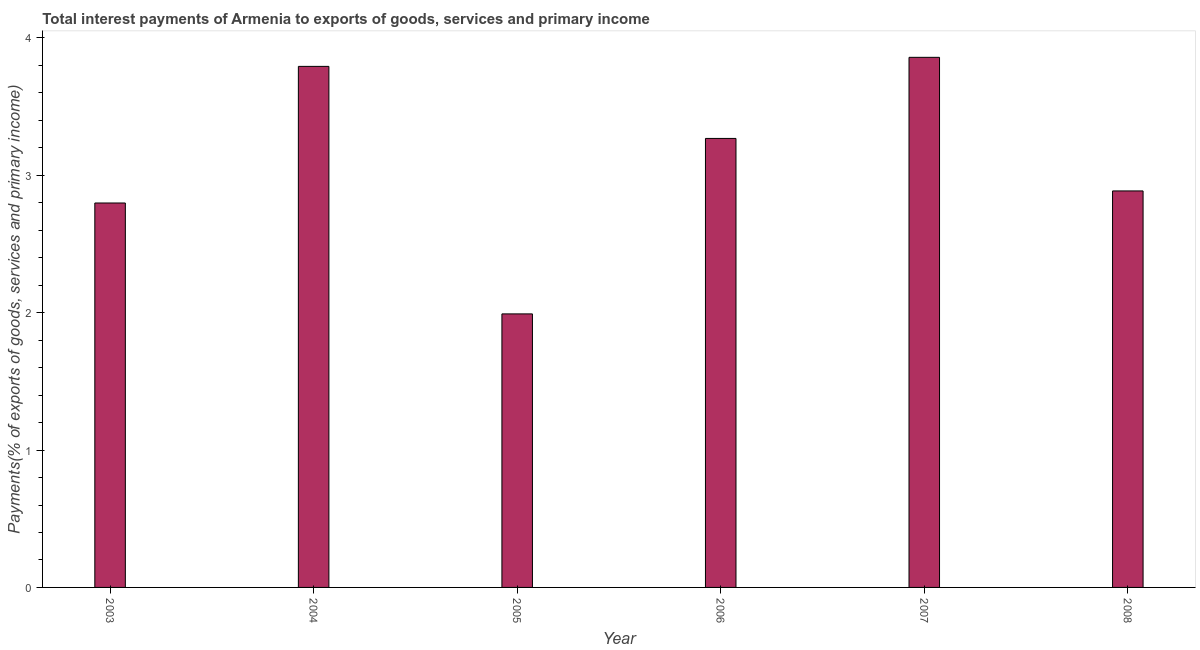What is the title of the graph?
Offer a very short reply. Total interest payments of Armenia to exports of goods, services and primary income. What is the label or title of the X-axis?
Offer a terse response. Year. What is the label or title of the Y-axis?
Ensure brevity in your answer.  Payments(% of exports of goods, services and primary income). What is the total interest payments on external debt in 2004?
Keep it short and to the point. 3.79. Across all years, what is the maximum total interest payments on external debt?
Your answer should be very brief. 3.86. Across all years, what is the minimum total interest payments on external debt?
Provide a short and direct response. 1.99. In which year was the total interest payments on external debt maximum?
Your answer should be compact. 2007. What is the sum of the total interest payments on external debt?
Ensure brevity in your answer.  18.6. What is the difference between the total interest payments on external debt in 2005 and 2008?
Offer a very short reply. -0.9. What is the average total interest payments on external debt per year?
Offer a very short reply. 3.1. What is the median total interest payments on external debt?
Provide a short and direct response. 3.08. Do a majority of the years between 2008 and 2004 (inclusive) have total interest payments on external debt greater than 1.4 %?
Provide a short and direct response. Yes. What is the ratio of the total interest payments on external debt in 2006 to that in 2008?
Keep it short and to the point. 1.13. Is the total interest payments on external debt in 2004 less than that in 2007?
Make the answer very short. Yes. What is the difference between the highest and the second highest total interest payments on external debt?
Give a very brief answer. 0.07. What is the difference between the highest and the lowest total interest payments on external debt?
Your response must be concise. 1.87. In how many years, is the total interest payments on external debt greater than the average total interest payments on external debt taken over all years?
Offer a terse response. 3. What is the Payments(% of exports of goods, services and primary income) of 2003?
Your response must be concise. 2.8. What is the Payments(% of exports of goods, services and primary income) in 2004?
Ensure brevity in your answer.  3.79. What is the Payments(% of exports of goods, services and primary income) of 2005?
Ensure brevity in your answer.  1.99. What is the Payments(% of exports of goods, services and primary income) in 2006?
Your answer should be very brief. 3.27. What is the Payments(% of exports of goods, services and primary income) of 2007?
Provide a short and direct response. 3.86. What is the Payments(% of exports of goods, services and primary income) of 2008?
Offer a terse response. 2.89. What is the difference between the Payments(% of exports of goods, services and primary income) in 2003 and 2004?
Provide a succinct answer. -0.99. What is the difference between the Payments(% of exports of goods, services and primary income) in 2003 and 2005?
Provide a succinct answer. 0.81. What is the difference between the Payments(% of exports of goods, services and primary income) in 2003 and 2006?
Offer a very short reply. -0.47. What is the difference between the Payments(% of exports of goods, services and primary income) in 2003 and 2007?
Offer a very short reply. -1.06. What is the difference between the Payments(% of exports of goods, services and primary income) in 2003 and 2008?
Give a very brief answer. -0.09. What is the difference between the Payments(% of exports of goods, services and primary income) in 2004 and 2005?
Provide a succinct answer. 1.8. What is the difference between the Payments(% of exports of goods, services and primary income) in 2004 and 2006?
Offer a very short reply. 0.52. What is the difference between the Payments(% of exports of goods, services and primary income) in 2004 and 2007?
Ensure brevity in your answer.  -0.07. What is the difference between the Payments(% of exports of goods, services and primary income) in 2004 and 2008?
Your answer should be compact. 0.91. What is the difference between the Payments(% of exports of goods, services and primary income) in 2005 and 2006?
Provide a short and direct response. -1.28. What is the difference between the Payments(% of exports of goods, services and primary income) in 2005 and 2007?
Keep it short and to the point. -1.87. What is the difference between the Payments(% of exports of goods, services and primary income) in 2005 and 2008?
Your answer should be very brief. -0.9. What is the difference between the Payments(% of exports of goods, services and primary income) in 2006 and 2007?
Your answer should be very brief. -0.59. What is the difference between the Payments(% of exports of goods, services and primary income) in 2006 and 2008?
Keep it short and to the point. 0.38. What is the difference between the Payments(% of exports of goods, services and primary income) in 2007 and 2008?
Ensure brevity in your answer.  0.97. What is the ratio of the Payments(% of exports of goods, services and primary income) in 2003 to that in 2004?
Keep it short and to the point. 0.74. What is the ratio of the Payments(% of exports of goods, services and primary income) in 2003 to that in 2005?
Provide a succinct answer. 1.41. What is the ratio of the Payments(% of exports of goods, services and primary income) in 2003 to that in 2006?
Your answer should be very brief. 0.86. What is the ratio of the Payments(% of exports of goods, services and primary income) in 2003 to that in 2007?
Your response must be concise. 0.72. What is the ratio of the Payments(% of exports of goods, services and primary income) in 2004 to that in 2005?
Make the answer very short. 1.91. What is the ratio of the Payments(% of exports of goods, services and primary income) in 2004 to that in 2006?
Offer a terse response. 1.16. What is the ratio of the Payments(% of exports of goods, services and primary income) in 2004 to that in 2007?
Ensure brevity in your answer.  0.98. What is the ratio of the Payments(% of exports of goods, services and primary income) in 2004 to that in 2008?
Your answer should be compact. 1.31. What is the ratio of the Payments(% of exports of goods, services and primary income) in 2005 to that in 2006?
Provide a short and direct response. 0.61. What is the ratio of the Payments(% of exports of goods, services and primary income) in 2005 to that in 2007?
Offer a very short reply. 0.52. What is the ratio of the Payments(% of exports of goods, services and primary income) in 2005 to that in 2008?
Your answer should be very brief. 0.69. What is the ratio of the Payments(% of exports of goods, services and primary income) in 2006 to that in 2007?
Keep it short and to the point. 0.85. What is the ratio of the Payments(% of exports of goods, services and primary income) in 2006 to that in 2008?
Ensure brevity in your answer.  1.13. What is the ratio of the Payments(% of exports of goods, services and primary income) in 2007 to that in 2008?
Your answer should be very brief. 1.34. 